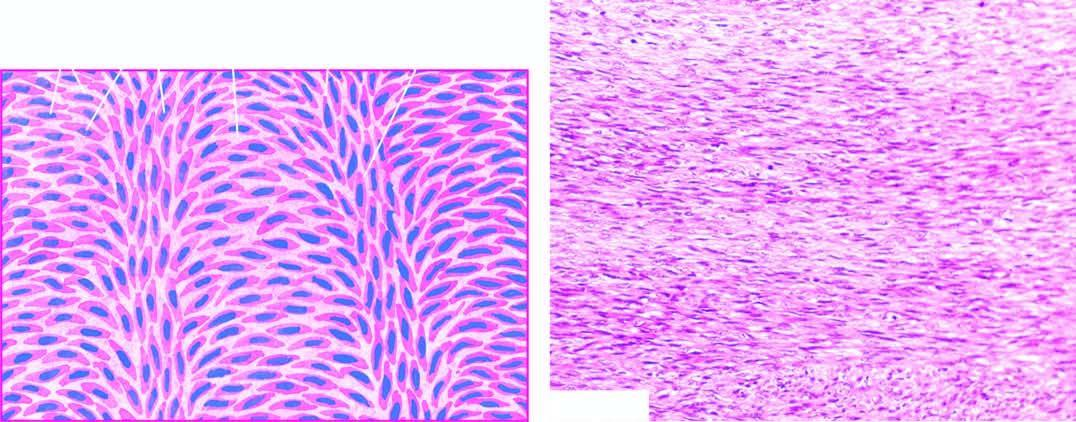what does microscopy show?
Answer the question using a single word or phrase. Microscopy 